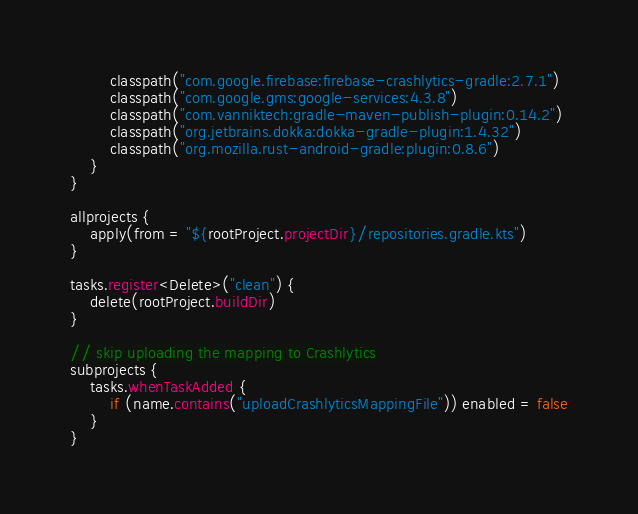Convert code to text. <code><loc_0><loc_0><loc_500><loc_500><_Kotlin_>        classpath("com.google.firebase:firebase-crashlytics-gradle:2.7.1")
        classpath("com.google.gms:google-services:4.3.8")
        classpath("com.vanniktech:gradle-maven-publish-plugin:0.14.2")
        classpath("org.jetbrains.dokka:dokka-gradle-plugin:1.4.32")
        classpath("org.mozilla.rust-android-gradle:plugin:0.8.6")
    }
}

allprojects {
    apply(from = "${rootProject.projectDir}/repositories.gradle.kts")
}

tasks.register<Delete>("clean") {
    delete(rootProject.buildDir)
}

// skip uploading the mapping to Crashlytics
subprojects {
    tasks.whenTaskAdded {
        if (name.contains("uploadCrashlyticsMappingFile")) enabled = false
    }
}
</code> 